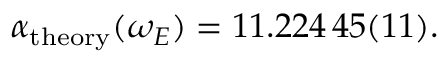Convert formula to latex. <formula><loc_0><loc_0><loc_500><loc_500>\begin{array} { r } { \alpha _ { t h e o r y } ( \omega _ { E } ) = 1 1 . 2 2 4 \, 4 5 ( 1 1 ) . } \end{array}</formula> 